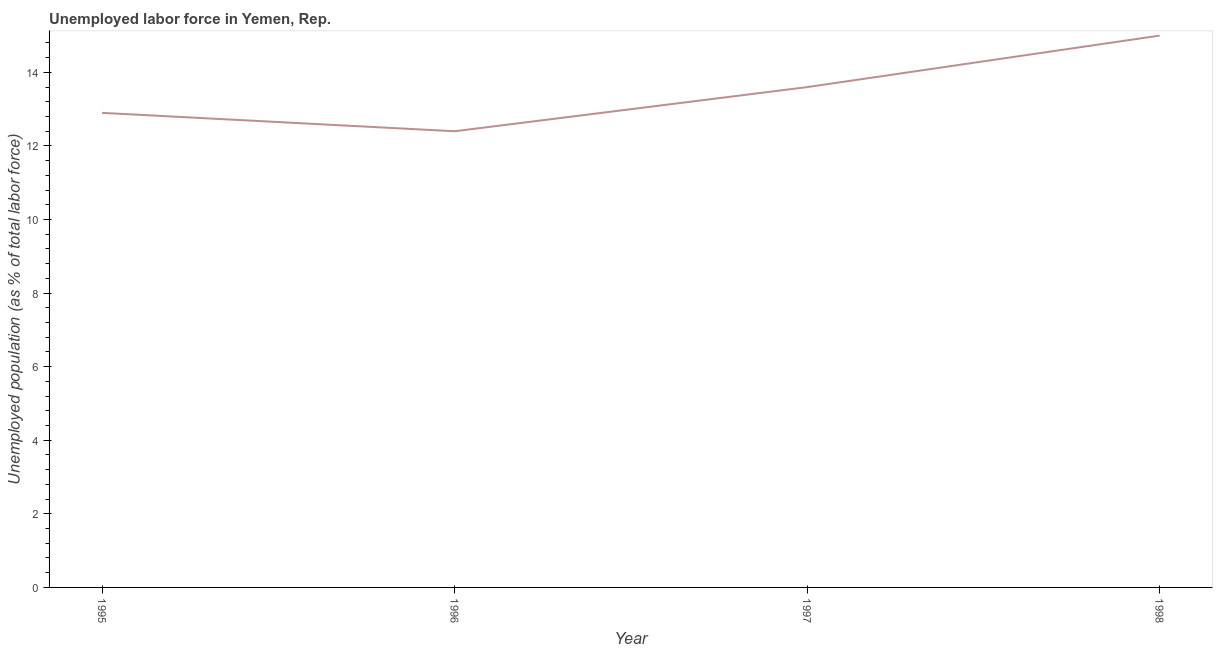What is the total unemployed population in 1995?
Make the answer very short. 12.9. Across all years, what is the maximum total unemployed population?
Offer a very short reply. 15. Across all years, what is the minimum total unemployed population?
Your answer should be compact. 12.4. In which year was the total unemployed population maximum?
Give a very brief answer. 1998. In which year was the total unemployed population minimum?
Provide a succinct answer. 1996. What is the sum of the total unemployed population?
Give a very brief answer. 53.9. What is the difference between the total unemployed population in 1995 and 1997?
Ensure brevity in your answer.  -0.7. What is the average total unemployed population per year?
Keep it short and to the point. 13.47. What is the median total unemployed population?
Offer a very short reply. 13.25. Do a majority of the years between 1998 and 1996 (inclusive) have total unemployed population greater than 12.8 %?
Give a very brief answer. No. What is the ratio of the total unemployed population in 1996 to that in 1997?
Ensure brevity in your answer.  0.91. What is the difference between the highest and the second highest total unemployed population?
Make the answer very short. 1.4. What is the difference between the highest and the lowest total unemployed population?
Give a very brief answer. 2.6. In how many years, is the total unemployed population greater than the average total unemployed population taken over all years?
Offer a very short reply. 2. Does the total unemployed population monotonically increase over the years?
Provide a succinct answer. No. How many years are there in the graph?
Give a very brief answer. 4. What is the difference between two consecutive major ticks on the Y-axis?
Your answer should be compact. 2. Are the values on the major ticks of Y-axis written in scientific E-notation?
Your response must be concise. No. Does the graph contain any zero values?
Offer a very short reply. No. What is the title of the graph?
Offer a very short reply. Unemployed labor force in Yemen, Rep. What is the label or title of the Y-axis?
Offer a terse response. Unemployed population (as % of total labor force). What is the Unemployed population (as % of total labor force) of 1995?
Provide a succinct answer. 12.9. What is the Unemployed population (as % of total labor force) in 1996?
Your response must be concise. 12.4. What is the Unemployed population (as % of total labor force) in 1997?
Your answer should be compact. 13.6. What is the Unemployed population (as % of total labor force) in 1998?
Your answer should be compact. 15. What is the difference between the Unemployed population (as % of total labor force) in 1995 and 1996?
Make the answer very short. 0.5. What is the difference between the Unemployed population (as % of total labor force) in 1995 and 1998?
Your response must be concise. -2.1. What is the difference between the Unemployed population (as % of total labor force) in 1997 and 1998?
Make the answer very short. -1.4. What is the ratio of the Unemployed population (as % of total labor force) in 1995 to that in 1996?
Make the answer very short. 1.04. What is the ratio of the Unemployed population (as % of total labor force) in 1995 to that in 1997?
Offer a terse response. 0.95. What is the ratio of the Unemployed population (as % of total labor force) in 1995 to that in 1998?
Offer a terse response. 0.86. What is the ratio of the Unemployed population (as % of total labor force) in 1996 to that in 1997?
Offer a very short reply. 0.91. What is the ratio of the Unemployed population (as % of total labor force) in 1996 to that in 1998?
Your answer should be very brief. 0.83. What is the ratio of the Unemployed population (as % of total labor force) in 1997 to that in 1998?
Your answer should be compact. 0.91. 